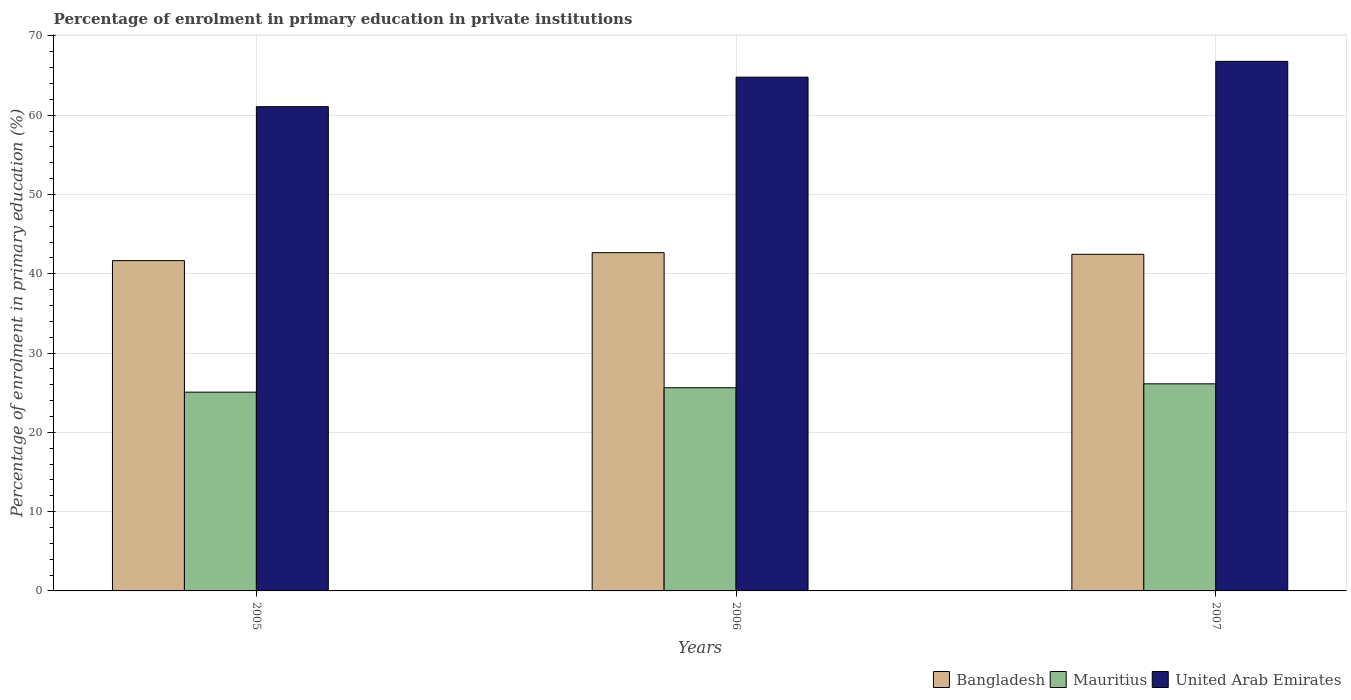Are the number of bars per tick equal to the number of legend labels?
Your response must be concise. Yes. What is the label of the 3rd group of bars from the left?
Provide a succinct answer. 2007. What is the percentage of enrolment in primary education in Mauritius in 2006?
Your answer should be very brief. 25.63. Across all years, what is the maximum percentage of enrolment in primary education in Mauritius?
Your answer should be compact. 26.12. Across all years, what is the minimum percentage of enrolment in primary education in Bangladesh?
Offer a terse response. 41.65. In which year was the percentage of enrolment in primary education in Mauritius maximum?
Offer a very short reply. 2007. What is the total percentage of enrolment in primary education in Mauritius in the graph?
Provide a short and direct response. 76.81. What is the difference between the percentage of enrolment in primary education in Bangladesh in 2005 and that in 2007?
Provide a succinct answer. -0.8. What is the difference between the percentage of enrolment in primary education in Bangladesh in 2005 and the percentage of enrolment in primary education in United Arab Emirates in 2006?
Make the answer very short. -23.14. What is the average percentage of enrolment in primary education in United Arab Emirates per year?
Make the answer very short. 64.21. In the year 2005, what is the difference between the percentage of enrolment in primary education in United Arab Emirates and percentage of enrolment in primary education in Mauritius?
Your answer should be compact. 36. What is the ratio of the percentage of enrolment in primary education in Mauritius in 2005 to that in 2007?
Ensure brevity in your answer.  0.96. Is the percentage of enrolment in primary education in Bangladesh in 2005 less than that in 2007?
Provide a short and direct response. Yes. What is the difference between the highest and the second highest percentage of enrolment in primary education in Mauritius?
Ensure brevity in your answer.  0.49. What is the difference between the highest and the lowest percentage of enrolment in primary education in Bangladesh?
Your answer should be very brief. 1.01. In how many years, is the percentage of enrolment in primary education in Bangladesh greater than the average percentage of enrolment in primary education in Bangladesh taken over all years?
Offer a very short reply. 2. Is the sum of the percentage of enrolment in primary education in United Arab Emirates in 2006 and 2007 greater than the maximum percentage of enrolment in primary education in Mauritius across all years?
Your answer should be very brief. Yes. What does the 3rd bar from the left in 2005 represents?
Give a very brief answer. United Arab Emirates. What does the 1st bar from the right in 2006 represents?
Provide a succinct answer. United Arab Emirates. Are all the bars in the graph horizontal?
Your answer should be compact. No. Are the values on the major ticks of Y-axis written in scientific E-notation?
Provide a short and direct response. No. Does the graph contain grids?
Give a very brief answer. Yes. Where does the legend appear in the graph?
Keep it short and to the point. Bottom right. How are the legend labels stacked?
Offer a very short reply. Horizontal. What is the title of the graph?
Make the answer very short. Percentage of enrolment in primary education in private institutions. Does "Russian Federation" appear as one of the legend labels in the graph?
Make the answer very short. No. What is the label or title of the Y-axis?
Your response must be concise. Percentage of enrolment in primary education (%). What is the Percentage of enrolment in primary education (%) of Bangladesh in 2005?
Provide a succinct answer. 41.65. What is the Percentage of enrolment in primary education (%) of Mauritius in 2005?
Ensure brevity in your answer.  25.07. What is the Percentage of enrolment in primary education (%) of United Arab Emirates in 2005?
Your answer should be very brief. 61.07. What is the Percentage of enrolment in primary education (%) of Bangladesh in 2006?
Make the answer very short. 42.66. What is the Percentage of enrolment in primary education (%) in Mauritius in 2006?
Give a very brief answer. 25.63. What is the Percentage of enrolment in primary education (%) of United Arab Emirates in 2006?
Provide a succinct answer. 64.79. What is the Percentage of enrolment in primary education (%) of Bangladesh in 2007?
Provide a succinct answer. 42.45. What is the Percentage of enrolment in primary education (%) in Mauritius in 2007?
Your answer should be very brief. 26.12. What is the Percentage of enrolment in primary education (%) of United Arab Emirates in 2007?
Provide a succinct answer. 66.78. Across all years, what is the maximum Percentage of enrolment in primary education (%) in Bangladesh?
Your answer should be compact. 42.66. Across all years, what is the maximum Percentage of enrolment in primary education (%) of Mauritius?
Keep it short and to the point. 26.12. Across all years, what is the maximum Percentage of enrolment in primary education (%) in United Arab Emirates?
Keep it short and to the point. 66.78. Across all years, what is the minimum Percentage of enrolment in primary education (%) of Bangladesh?
Provide a succinct answer. 41.65. Across all years, what is the minimum Percentage of enrolment in primary education (%) in Mauritius?
Your response must be concise. 25.07. Across all years, what is the minimum Percentage of enrolment in primary education (%) in United Arab Emirates?
Give a very brief answer. 61.07. What is the total Percentage of enrolment in primary education (%) of Bangladesh in the graph?
Keep it short and to the point. 126.76. What is the total Percentage of enrolment in primary education (%) of Mauritius in the graph?
Offer a very short reply. 76.81. What is the total Percentage of enrolment in primary education (%) of United Arab Emirates in the graph?
Offer a terse response. 192.64. What is the difference between the Percentage of enrolment in primary education (%) in Bangladesh in 2005 and that in 2006?
Make the answer very short. -1.01. What is the difference between the Percentage of enrolment in primary education (%) of Mauritius in 2005 and that in 2006?
Provide a succinct answer. -0.56. What is the difference between the Percentage of enrolment in primary education (%) of United Arab Emirates in 2005 and that in 2006?
Keep it short and to the point. -3.72. What is the difference between the Percentage of enrolment in primary education (%) of Bangladesh in 2005 and that in 2007?
Provide a short and direct response. -0.8. What is the difference between the Percentage of enrolment in primary education (%) in Mauritius in 2005 and that in 2007?
Your answer should be very brief. -1.05. What is the difference between the Percentage of enrolment in primary education (%) in United Arab Emirates in 2005 and that in 2007?
Your answer should be very brief. -5.72. What is the difference between the Percentage of enrolment in primary education (%) of Bangladesh in 2006 and that in 2007?
Give a very brief answer. 0.21. What is the difference between the Percentage of enrolment in primary education (%) of Mauritius in 2006 and that in 2007?
Provide a succinct answer. -0.49. What is the difference between the Percentage of enrolment in primary education (%) in United Arab Emirates in 2006 and that in 2007?
Make the answer very short. -1.99. What is the difference between the Percentage of enrolment in primary education (%) of Bangladesh in 2005 and the Percentage of enrolment in primary education (%) of Mauritius in 2006?
Offer a terse response. 16.03. What is the difference between the Percentage of enrolment in primary education (%) of Bangladesh in 2005 and the Percentage of enrolment in primary education (%) of United Arab Emirates in 2006?
Offer a very short reply. -23.14. What is the difference between the Percentage of enrolment in primary education (%) of Mauritius in 2005 and the Percentage of enrolment in primary education (%) of United Arab Emirates in 2006?
Make the answer very short. -39.72. What is the difference between the Percentage of enrolment in primary education (%) in Bangladesh in 2005 and the Percentage of enrolment in primary education (%) in Mauritius in 2007?
Provide a short and direct response. 15.54. What is the difference between the Percentage of enrolment in primary education (%) in Bangladesh in 2005 and the Percentage of enrolment in primary education (%) in United Arab Emirates in 2007?
Ensure brevity in your answer.  -25.13. What is the difference between the Percentage of enrolment in primary education (%) in Mauritius in 2005 and the Percentage of enrolment in primary education (%) in United Arab Emirates in 2007?
Offer a terse response. -41.72. What is the difference between the Percentage of enrolment in primary education (%) of Bangladesh in 2006 and the Percentage of enrolment in primary education (%) of Mauritius in 2007?
Offer a terse response. 16.54. What is the difference between the Percentage of enrolment in primary education (%) of Bangladesh in 2006 and the Percentage of enrolment in primary education (%) of United Arab Emirates in 2007?
Offer a terse response. -24.13. What is the difference between the Percentage of enrolment in primary education (%) in Mauritius in 2006 and the Percentage of enrolment in primary education (%) in United Arab Emirates in 2007?
Offer a terse response. -41.16. What is the average Percentage of enrolment in primary education (%) of Bangladesh per year?
Offer a terse response. 42.25. What is the average Percentage of enrolment in primary education (%) of Mauritius per year?
Provide a short and direct response. 25.6. What is the average Percentage of enrolment in primary education (%) in United Arab Emirates per year?
Give a very brief answer. 64.21. In the year 2005, what is the difference between the Percentage of enrolment in primary education (%) in Bangladesh and Percentage of enrolment in primary education (%) in Mauritius?
Keep it short and to the point. 16.59. In the year 2005, what is the difference between the Percentage of enrolment in primary education (%) in Bangladesh and Percentage of enrolment in primary education (%) in United Arab Emirates?
Make the answer very short. -19.42. In the year 2005, what is the difference between the Percentage of enrolment in primary education (%) of Mauritius and Percentage of enrolment in primary education (%) of United Arab Emirates?
Provide a succinct answer. -36. In the year 2006, what is the difference between the Percentage of enrolment in primary education (%) of Bangladesh and Percentage of enrolment in primary education (%) of Mauritius?
Provide a succinct answer. 17.03. In the year 2006, what is the difference between the Percentage of enrolment in primary education (%) of Bangladesh and Percentage of enrolment in primary education (%) of United Arab Emirates?
Offer a terse response. -22.13. In the year 2006, what is the difference between the Percentage of enrolment in primary education (%) in Mauritius and Percentage of enrolment in primary education (%) in United Arab Emirates?
Your response must be concise. -39.16. In the year 2007, what is the difference between the Percentage of enrolment in primary education (%) of Bangladesh and Percentage of enrolment in primary education (%) of Mauritius?
Provide a short and direct response. 16.34. In the year 2007, what is the difference between the Percentage of enrolment in primary education (%) of Bangladesh and Percentage of enrolment in primary education (%) of United Arab Emirates?
Offer a terse response. -24.33. In the year 2007, what is the difference between the Percentage of enrolment in primary education (%) of Mauritius and Percentage of enrolment in primary education (%) of United Arab Emirates?
Keep it short and to the point. -40.67. What is the ratio of the Percentage of enrolment in primary education (%) of Bangladesh in 2005 to that in 2006?
Keep it short and to the point. 0.98. What is the ratio of the Percentage of enrolment in primary education (%) of Mauritius in 2005 to that in 2006?
Your answer should be compact. 0.98. What is the ratio of the Percentage of enrolment in primary education (%) of United Arab Emirates in 2005 to that in 2006?
Give a very brief answer. 0.94. What is the ratio of the Percentage of enrolment in primary education (%) of Bangladesh in 2005 to that in 2007?
Provide a succinct answer. 0.98. What is the ratio of the Percentage of enrolment in primary education (%) in Mauritius in 2005 to that in 2007?
Make the answer very short. 0.96. What is the ratio of the Percentage of enrolment in primary education (%) of United Arab Emirates in 2005 to that in 2007?
Your response must be concise. 0.91. What is the ratio of the Percentage of enrolment in primary education (%) of Mauritius in 2006 to that in 2007?
Provide a short and direct response. 0.98. What is the ratio of the Percentage of enrolment in primary education (%) in United Arab Emirates in 2006 to that in 2007?
Your answer should be very brief. 0.97. What is the difference between the highest and the second highest Percentage of enrolment in primary education (%) of Bangladesh?
Provide a short and direct response. 0.21. What is the difference between the highest and the second highest Percentage of enrolment in primary education (%) of Mauritius?
Offer a terse response. 0.49. What is the difference between the highest and the second highest Percentage of enrolment in primary education (%) of United Arab Emirates?
Provide a short and direct response. 1.99. What is the difference between the highest and the lowest Percentage of enrolment in primary education (%) in Bangladesh?
Provide a succinct answer. 1.01. What is the difference between the highest and the lowest Percentage of enrolment in primary education (%) of Mauritius?
Your answer should be compact. 1.05. What is the difference between the highest and the lowest Percentage of enrolment in primary education (%) in United Arab Emirates?
Your answer should be very brief. 5.72. 